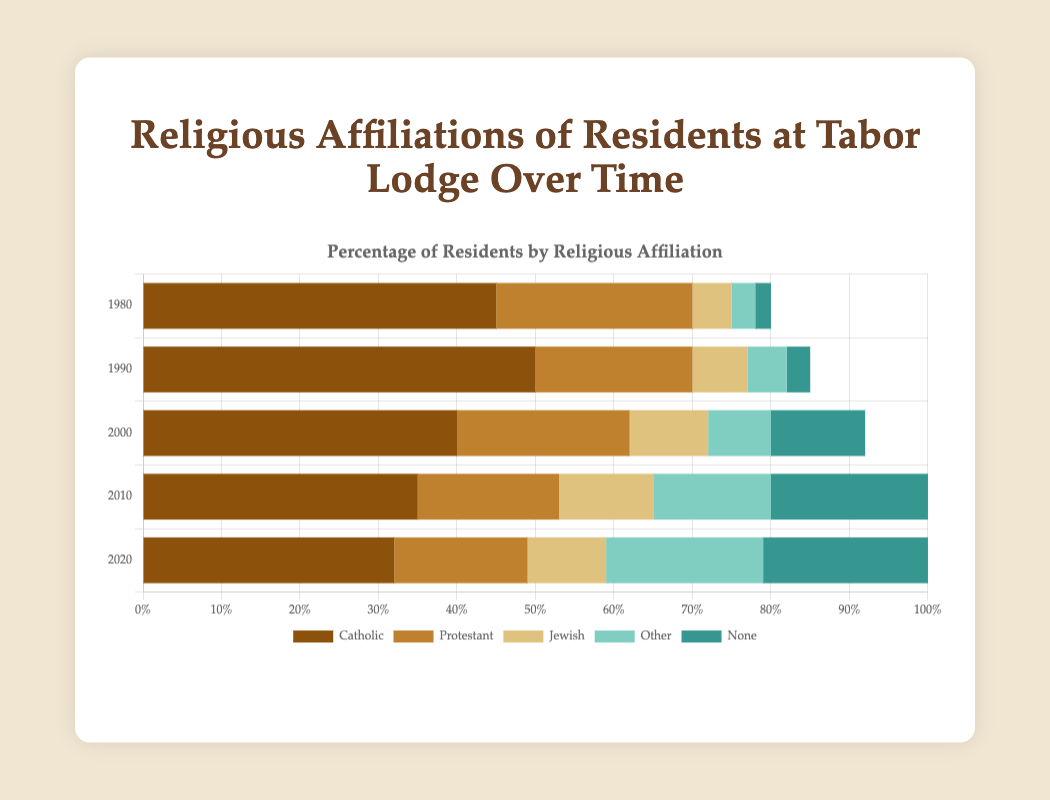Which religious affiliation had the highest percentage in 1980? Looking at the year 1980 on the horizontal stacked bar chart, the Catholic segment has the longest bar compared to the other religious affiliations.
Answer: Catholic How did the percentage of residents with no religious affiliation change from 2000 to 2020? In 2000, the 'None' segment was 12%, and in 2020, it increased to 25%. Calculating the difference, 25% - 12% = 13%.
Answer: Increased by 13% Which year showed the highest percentage of Protestant residents? Comparing the lengths of the Protestant segments for each year on the chart, the year 1980 had the highest with 25%.
Answer: 1980 Between 1990 and 2010, which religious affiliation showed the greatest increase in percentage? Comparing the respective affiliations: Catholic (50% to 35%), Protestant (20% to 18%), Jewish (7% to 12%), Other (5% to 15%), None (3% to 20%). The category 'None' shows the greatest increase.
Answer: None What was the combined percentage of Jewish and Other affiliations in 2020? Jewish has 10% and Other has 20% for the year 2020. Summing these, 10% + 20% = 30%.
Answer: 30% In which year did the 'Other' affiliation first surpass 10%? Reviewing each year in the chart for the 'Other' category, it surpasses 10% for the first time in 2010.
Answer: 2010 What is the average percentage of Catholic residents over the decades presented? Averaging the Catholic percentages over the given years: (45% + 50% + 40% + 35% + 32%) / 5 = 40.4%.
Answer: 40.4% Compare the change in percentage for Jewish and Catholic affiliations from 1980 to 2020. Which one decreased more? Catholic decreased from 45% to 32%, a decrease of 13%. Jewish increased from 5% to 10%, so its change was actually an increase.
Answer: Catholic decreased more What is the total percentage of residents identifying as religious (Catholic, Protestant, Jewish, Other) in 2010? Summing the percentages of religious affiliations (Catholic, Protestant, Jewish, Other) for 2010: 35% + 18% + 12% + 15% = 80%.
Answer: 80% 